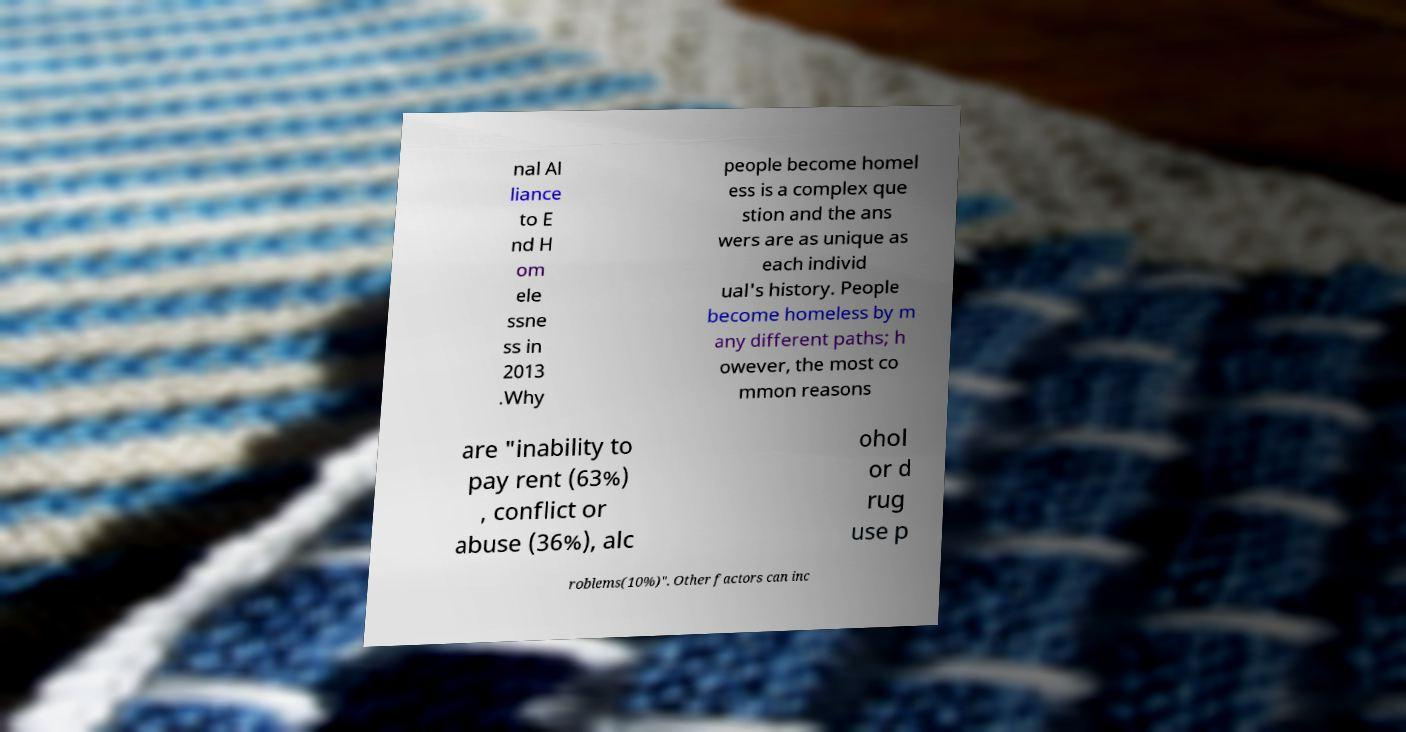For documentation purposes, I need the text within this image transcribed. Could you provide that? nal Al liance to E nd H om ele ssne ss in 2013 .Why people become homel ess is a complex que stion and the ans wers are as unique as each individ ual's history. People become homeless by m any different paths; h owever, the most co mmon reasons are "inability to pay rent (63%) , conflict or abuse (36%), alc ohol or d rug use p roblems(10%)". Other factors can inc 